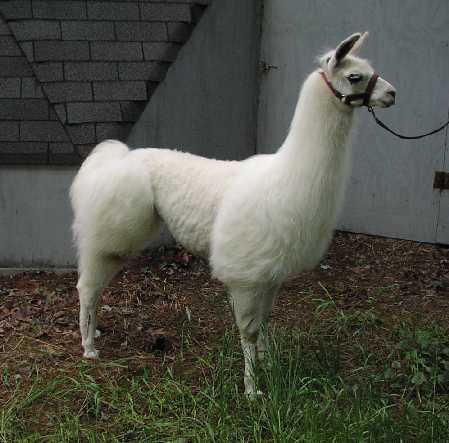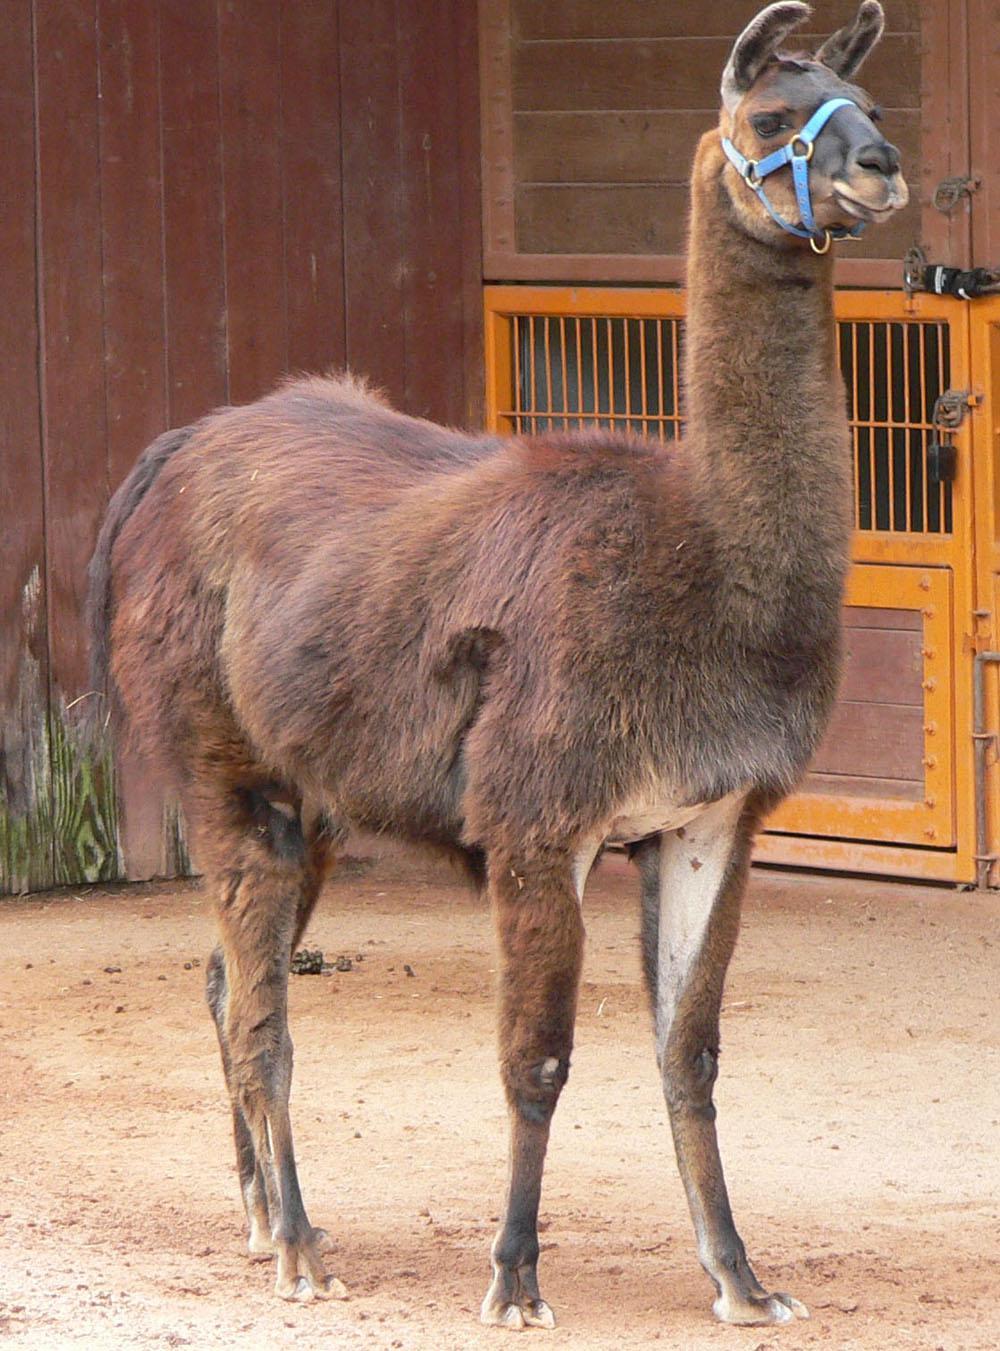The first image is the image on the left, the second image is the image on the right. Given the left and right images, does the statement "In the right image, a baby llama with its body turned left and its head turned right is standing near a standing adult llama." hold true? Answer yes or no. No. The first image is the image on the left, the second image is the image on the right. Assess this claim about the two images: "One of the images show only two llamas that are facing the same direction as the other.". Correct or not? Answer yes or no. No. 